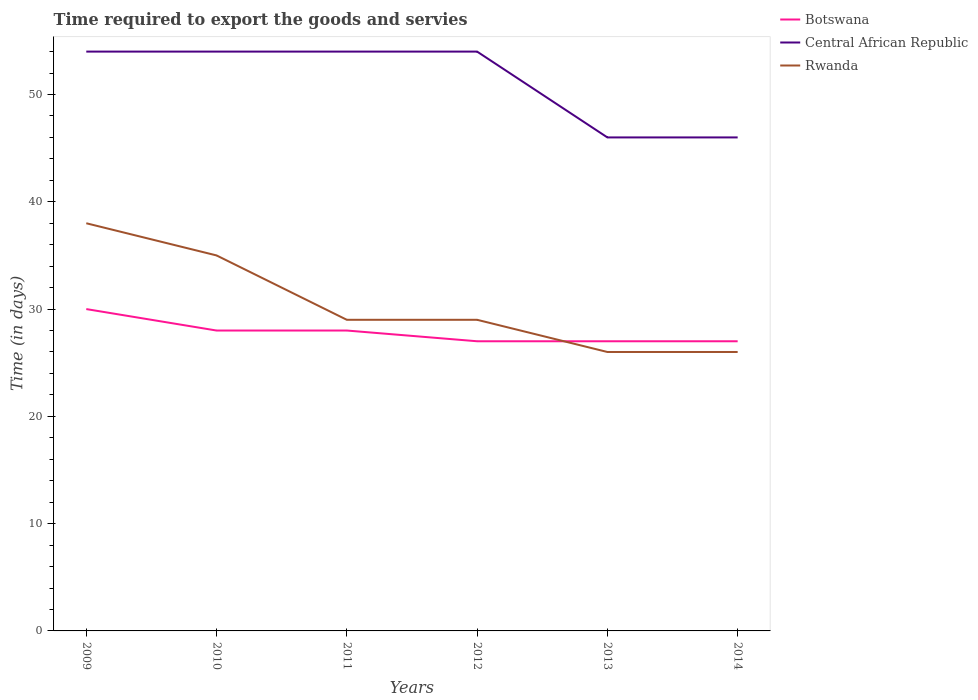How many different coloured lines are there?
Make the answer very short. 3. Does the line corresponding to Rwanda intersect with the line corresponding to Central African Republic?
Your answer should be very brief. No. Is the number of lines equal to the number of legend labels?
Keep it short and to the point. Yes. Across all years, what is the maximum number of days required to export the goods and services in Rwanda?
Your answer should be very brief. 26. In which year was the number of days required to export the goods and services in Central African Republic maximum?
Provide a short and direct response. 2013. What is the total number of days required to export the goods and services in Central African Republic in the graph?
Provide a short and direct response. 8. What is the difference between the highest and the second highest number of days required to export the goods and services in Central African Republic?
Make the answer very short. 8. How many lines are there?
Provide a short and direct response. 3. Does the graph contain any zero values?
Provide a short and direct response. No. Does the graph contain grids?
Offer a very short reply. No. How many legend labels are there?
Keep it short and to the point. 3. How are the legend labels stacked?
Offer a very short reply. Vertical. What is the title of the graph?
Provide a succinct answer. Time required to export the goods and servies. Does "American Samoa" appear as one of the legend labels in the graph?
Keep it short and to the point. No. What is the label or title of the Y-axis?
Give a very brief answer. Time (in days). What is the Time (in days) in Botswana in 2009?
Offer a terse response. 30. What is the Time (in days) in Botswana in 2010?
Keep it short and to the point. 28. What is the Time (in days) in Central African Republic in 2010?
Your answer should be compact. 54. What is the Time (in days) of Rwanda in 2010?
Keep it short and to the point. 35. What is the Time (in days) of Central African Republic in 2011?
Your answer should be compact. 54. What is the Time (in days) in Botswana in 2012?
Give a very brief answer. 27. What is the Time (in days) in Central African Republic in 2012?
Provide a succinct answer. 54. What is the Time (in days) in Botswana in 2013?
Provide a succinct answer. 27. What is the Time (in days) in Central African Republic in 2013?
Give a very brief answer. 46. What is the Time (in days) of Rwanda in 2013?
Make the answer very short. 26. What is the Time (in days) in Central African Republic in 2014?
Your answer should be compact. 46. What is the Time (in days) in Rwanda in 2014?
Provide a short and direct response. 26. Across all years, what is the minimum Time (in days) of Botswana?
Make the answer very short. 27. Across all years, what is the minimum Time (in days) of Central African Republic?
Give a very brief answer. 46. What is the total Time (in days) in Botswana in the graph?
Your answer should be compact. 167. What is the total Time (in days) in Central African Republic in the graph?
Ensure brevity in your answer.  308. What is the total Time (in days) in Rwanda in the graph?
Ensure brevity in your answer.  183. What is the difference between the Time (in days) in Botswana in 2009 and that in 2010?
Ensure brevity in your answer.  2. What is the difference between the Time (in days) of Central African Republic in 2009 and that in 2010?
Keep it short and to the point. 0. What is the difference between the Time (in days) of Botswana in 2009 and that in 2011?
Offer a very short reply. 2. What is the difference between the Time (in days) in Central African Republic in 2009 and that in 2011?
Your response must be concise. 0. What is the difference between the Time (in days) in Central African Republic in 2009 and that in 2012?
Make the answer very short. 0. What is the difference between the Time (in days) of Botswana in 2009 and that in 2014?
Provide a short and direct response. 3. What is the difference between the Time (in days) in Rwanda in 2009 and that in 2014?
Give a very brief answer. 12. What is the difference between the Time (in days) in Botswana in 2010 and that in 2011?
Your answer should be very brief. 0. What is the difference between the Time (in days) of Central African Republic in 2010 and that in 2011?
Your answer should be very brief. 0. What is the difference between the Time (in days) of Central African Republic in 2010 and that in 2012?
Provide a short and direct response. 0. What is the difference between the Time (in days) of Botswana in 2010 and that in 2013?
Offer a terse response. 1. What is the difference between the Time (in days) of Rwanda in 2010 and that in 2013?
Your response must be concise. 9. What is the difference between the Time (in days) of Central African Republic in 2011 and that in 2012?
Ensure brevity in your answer.  0. What is the difference between the Time (in days) of Rwanda in 2011 and that in 2012?
Give a very brief answer. 0. What is the difference between the Time (in days) in Central African Republic in 2011 and that in 2013?
Your answer should be compact. 8. What is the difference between the Time (in days) in Botswana in 2011 and that in 2014?
Your response must be concise. 1. What is the difference between the Time (in days) of Rwanda in 2011 and that in 2014?
Provide a short and direct response. 3. What is the difference between the Time (in days) of Botswana in 2012 and that in 2013?
Your answer should be very brief. 0. What is the difference between the Time (in days) in Central African Republic in 2012 and that in 2013?
Keep it short and to the point. 8. What is the difference between the Time (in days) of Botswana in 2012 and that in 2014?
Your response must be concise. 0. What is the difference between the Time (in days) of Central African Republic in 2012 and that in 2014?
Your answer should be compact. 8. What is the difference between the Time (in days) in Rwanda in 2012 and that in 2014?
Your answer should be compact. 3. What is the difference between the Time (in days) in Botswana in 2013 and that in 2014?
Provide a succinct answer. 0. What is the difference between the Time (in days) of Botswana in 2009 and the Time (in days) of Central African Republic in 2011?
Give a very brief answer. -24. What is the difference between the Time (in days) in Botswana in 2009 and the Time (in days) in Rwanda in 2011?
Make the answer very short. 1. What is the difference between the Time (in days) of Central African Republic in 2009 and the Time (in days) of Rwanda in 2011?
Offer a very short reply. 25. What is the difference between the Time (in days) in Botswana in 2009 and the Time (in days) in Central African Republic in 2012?
Provide a short and direct response. -24. What is the difference between the Time (in days) in Botswana in 2009 and the Time (in days) in Rwanda in 2012?
Provide a short and direct response. 1. What is the difference between the Time (in days) in Central African Republic in 2009 and the Time (in days) in Rwanda in 2012?
Your response must be concise. 25. What is the difference between the Time (in days) in Botswana in 2009 and the Time (in days) in Central African Republic in 2013?
Give a very brief answer. -16. What is the difference between the Time (in days) of Central African Republic in 2009 and the Time (in days) of Rwanda in 2013?
Keep it short and to the point. 28. What is the difference between the Time (in days) of Central African Republic in 2010 and the Time (in days) of Rwanda in 2011?
Your answer should be very brief. 25. What is the difference between the Time (in days) of Botswana in 2010 and the Time (in days) of Central African Republic in 2012?
Provide a succinct answer. -26. What is the difference between the Time (in days) in Central African Republic in 2010 and the Time (in days) in Rwanda in 2012?
Your answer should be very brief. 25. What is the difference between the Time (in days) of Botswana in 2010 and the Time (in days) of Central African Republic in 2013?
Provide a short and direct response. -18. What is the difference between the Time (in days) in Botswana in 2010 and the Time (in days) in Central African Republic in 2014?
Your response must be concise. -18. What is the difference between the Time (in days) of Central African Republic in 2010 and the Time (in days) of Rwanda in 2014?
Ensure brevity in your answer.  28. What is the difference between the Time (in days) in Botswana in 2011 and the Time (in days) in Rwanda in 2012?
Offer a terse response. -1. What is the difference between the Time (in days) in Central African Republic in 2011 and the Time (in days) in Rwanda in 2012?
Offer a terse response. 25. What is the difference between the Time (in days) in Botswana in 2011 and the Time (in days) in Rwanda in 2013?
Your answer should be compact. 2. What is the difference between the Time (in days) in Central African Republic in 2011 and the Time (in days) in Rwanda in 2013?
Your response must be concise. 28. What is the difference between the Time (in days) in Central African Republic in 2011 and the Time (in days) in Rwanda in 2014?
Give a very brief answer. 28. What is the difference between the Time (in days) in Botswana in 2012 and the Time (in days) in Central African Republic in 2013?
Your response must be concise. -19. What is the difference between the Time (in days) in Botswana in 2012 and the Time (in days) in Rwanda in 2013?
Offer a very short reply. 1. What is the difference between the Time (in days) in Botswana in 2013 and the Time (in days) in Central African Republic in 2014?
Provide a succinct answer. -19. What is the difference between the Time (in days) in Central African Republic in 2013 and the Time (in days) in Rwanda in 2014?
Ensure brevity in your answer.  20. What is the average Time (in days) of Botswana per year?
Ensure brevity in your answer.  27.83. What is the average Time (in days) in Central African Republic per year?
Offer a terse response. 51.33. What is the average Time (in days) of Rwanda per year?
Offer a terse response. 30.5. In the year 2009, what is the difference between the Time (in days) in Botswana and Time (in days) in Central African Republic?
Offer a very short reply. -24. In the year 2009, what is the difference between the Time (in days) of Botswana and Time (in days) of Rwanda?
Your answer should be compact. -8. In the year 2009, what is the difference between the Time (in days) of Central African Republic and Time (in days) of Rwanda?
Your response must be concise. 16. In the year 2010, what is the difference between the Time (in days) of Botswana and Time (in days) of Central African Republic?
Offer a very short reply. -26. In the year 2010, what is the difference between the Time (in days) of Botswana and Time (in days) of Rwanda?
Offer a terse response. -7. In the year 2011, what is the difference between the Time (in days) in Botswana and Time (in days) in Central African Republic?
Provide a succinct answer. -26. In the year 2011, what is the difference between the Time (in days) of Central African Republic and Time (in days) of Rwanda?
Your answer should be very brief. 25. In the year 2012, what is the difference between the Time (in days) of Botswana and Time (in days) of Central African Republic?
Ensure brevity in your answer.  -27. In the year 2012, what is the difference between the Time (in days) of Botswana and Time (in days) of Rwanda?
Make the answer very short. -2. In the year 2013, what is the difference between the Time (in days) in Botswana and Time (in days) in Central African Republic?
Your answer should be very brief. -19. In the year 2014, what is the difference between the Time (in days) in Botswana and Time (in days) in Central African Republic?
Offer a terse response. -19. In the year 2014, what is the difference between the Time (in days) in Botswana and Time (in days) in Rwanda?
Provide a succinct answer. 1. What is the ratio of the Time (in days) in Botswana in 2009 to that in 2010?
Your answer should be compact. 1.07. What is the ratio of the Time (in days) of Central African Republic in 2009 to that in 2010?
Offer a terse response. 1. What is the ratio of the Time (in days) of Rwanda in 2009 to that in 2010?
Make the answer very short. 1.09. What is the ratio of the Time (in days) in Botswana in 2009 to that in 2011?
Keep it short and to the point. 1.07. What is the ratio of the Time (in days) in Central African Republic in 2009 to that in 2011?
Ensure brevity in your answer.  1. What is the ratio of the Time (in days) of Rwanda in 2009 to that in 2011?
Ensure brevity in your answer.  1.31. What is the ratio of the Time (in days) of Botswana in 2009 to that in 2012?
Give a very brief answer. 1.11. What is the ratio of the Time (in days) in Central African Republic in 2009 to that in 2012?
Provide a succinct answer. 1. What is the ratio of the Time (in days) of Rwanda in 2009 to that in 2012?
Provide a succinct answer. 1.31. What is the ratio of the Time (in days) in Botswana in 2009 to that in 2013?
Offer a terse response. 1.11. What is the ratio of the Time (in days) in Central African Republic in 2009 to that in 2013?
Make the answer very short. 1.17. What is the ratio of the Time (in days) of Rwanda in 2009 to that in 2013?
Make the answer very short. 1.46. What is the ratio of the Time (in days) of Botswana in 2009 to that in 2014?
Ensure brevity in your answer.  1.11. What is the ratio of the Time (in days) in Central African Republic in 2009 to that in 2014?
Ensure brevity in your answer.  1.17. What is the ratio of the Time (in days) of Rwanda in 2009 to that in 2014?
Give a very brief answer. 1.46. What is the ratio of the Time (in days) in Botswana in 2010 to that in 2011?
Provide a succinct answer. 1. What is the ratio of the Time (in days) of Central African Republic in 2010 to that in 2011?
Keep it short and to the point. 1. What is the ratio of the Time (in days) of Rwanda in 2010 to that in 2011?
Keep it short and to the point. 1.21. What is the ratio of the Time (in days) of Botswana in 2010 to that in 2012?
Your answer should be compact. 1.04. What is the ratio of the Time (in days) of Central African Republic in 2010 to that in 2012?
Ensure brevity in your answer.  1. What is the ratio of the Time (in days) in Rwanda in 2010 to that in 2012?
Your answer should be very brief. 1.21. What is the ratio of the Time (in days) of Botswana in 2010 to that in 2013?
Offer a very short reply. 1.04. What is the ratio of the Time (in days) of Central African Republic in 2010 to that in 2013?
Give a very brief answer. 1.17. What is the ratio of the Time (in days) of Rwanda in 2010 to that in 2013?
Offer a terse response. 1.35. What is the ratio of the Time (in days) in Botswana in 2010 to that in 2014?
Offer a terse response. 1.04. What is the ratio of the Time (in days) of Central African Republic in 2010 to that in 2014?
Offer a terse response. 1.17. What is the ratio of the Time (in days) in Rwanda in 2010 to that in 2014?
Offer a very short reply. 1.35. What is the ratio of the Time (in days) in Central African Republic in 2011 to that in 2012?
Provide a succinct answer. 1. What is the ratio of the Time (in days) in Rwanda in 2011 to that in 2012?
Offer a very short reply. 1. What is the ratio of the Time (in days) in Botswana in 2011 to that in 2013?
Give a very brief answer. 1.04. What is the ratio of the Time (in days) of Central African Republic in 2011 to that in 2013?
Provide a succinct answer. 1.17. What is the ratio of the Time (in days) in Rwanda in 2011 to that in 2013?
Your answer should be compact. 1.12. What is the ratio of the Time (in days) of Central African Republic in 2011 to that in 2014?
Ensure brevity in your answer.  1.17. What is the ratio of the Time (in days) of Rwanda in 2011 to that in 2014?
Make the answer very short. 1.12. What is the ratio of the Time (in days) in Central African Republic in 2012 to that in 2013?
Your response must be concise. 1.17. What is the ratio of the Time (in days) of Rwanda in 2012 to that in 2013?
Give a very brief answer. 1.12. What is the ratio of the Time (in days) of Botswana in 2012 to that in 2014?
Ensure brevity in your answer.  1. What is the ratio of the Time (in days) in Central African Republic in 2012 to that in 2014?
Offer a very short reply. 1.17. What is the ratio of the Time (in days) of Rwanda in 2012 to that in 2014?
Offer a very short reply. 1.12. What is the ratio of the Time (in days) of Rwanda in 2013 to that in 2014?
Your response must be concise. 1. What is the difference between the highest and the second highest Time (in days) in Rwanda?
Offer a terse response. 3. 